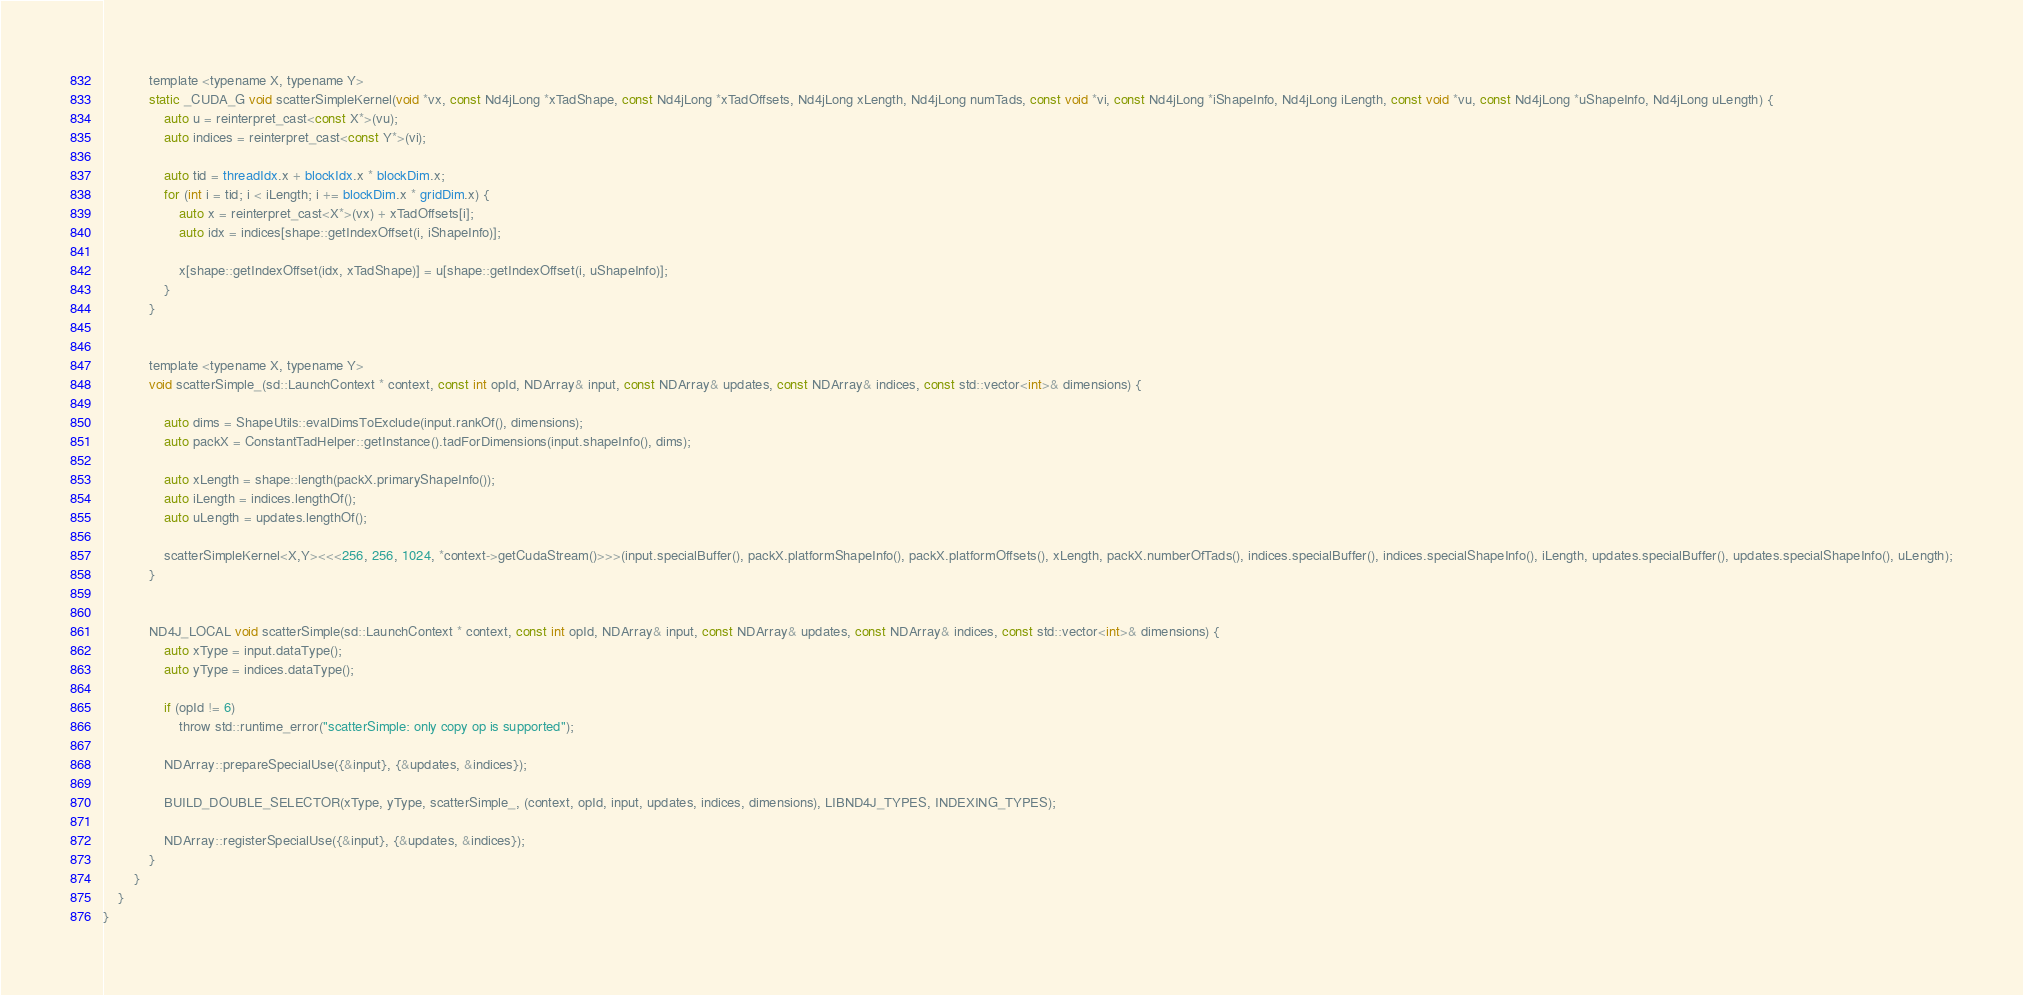Convert code to text. <code><loc_0><loc_0><loc_500><loc_500><_Cuda_>            template <typename X, typename Y>
            static _CUDA_G void scatterSimpleKernel(void *vx, const Nd4jLong *xTadShape, const Nd4jLong *xTadOffsets, Nd4jLong xLength, Nd4jLong numTads, const void *vi, const Nd4jLong *iShapeInfo, Nd4jLong iLength, const void *vu, const Nd4jLong *uShapeInfo, Nd4jLong uLength) {
                auto u = reinterpret_cast<const X*>(vu);
                auto indices = reinterpret_cast<const Y*>(vi);

                auto tid = threadIdx.x + blockIdx.x * blockDim.x;
                for (int i = tid; i < iLength; i += blockDim.x * gridDim.x) {
                    auto x = reinterpret_cast<X*>(vx) + xTadOffsets[i];
                    auto idx = indices[shape::getIndexOffset(i, iShapeInfo)];

                    x[shape::getIndexOffset(idx, xTadShape)] = u[shape::getIndexOffset(i, uShapeInfo)];
                }
            }


            template <typename X, typename Y>
            void scatterSimple_(sd::LaunchContext * context, const int opId, NDArray& input, const NDArray& updates, const NDArray& indices, const std::vector<int>& dimensions) {

                auto dims = ShapeUtils::evalDimsToExclude(input.rankOf(), dimensions);
                auto packX = ConstantTadHelper::getInstance().tadForDimensions(input.shapeInfo(), dims);

                auto xLength = shape::length(packX.primaryShapeInfo());
                auto iLength = indices.lengthOf();
                auto uLength = updates.lengthOf();

                scatterSimpleKernel<X,Y><<<256, 256, 1024, *context->getCudaStream()>>>(input.specialBuffer(), packX.platformShapeInfo(), packX.platformOffsets(), xLength, packX.numberOfTads(), indices.specialBuffer(), indices.specialShapeInfo(), iLength, updates.specialBuffer(), updates.specialShapeInfo(), uLength);
            }


            ND4J_LOCAL void scatterSimple(sd::LaunchContext * context, const int opId, NDArray& input, const NDArray& updates, const NDArray& indices, const std::vector<int>& dimensions) {
                auto xType = input.dataType();
                auto yType = indices.dataType();

                if (opId != 6)
                    throw std::runtime_error("scatterSimple: only copy op is supported");

                NDArray::prepareSpecialUse({&input}, {&updates, &indices});

                BUILD_DOUBLE_SELECTOR(xType, yType, scatterSimple_, (context, opId, input, updates, indices, dimensions), LIBND4J_TYPES, INDEXING_TYPES);

                NDArray::registerSpecialUse({&input}, {&updates, &indices});
            }
        }
    }
}</code> 